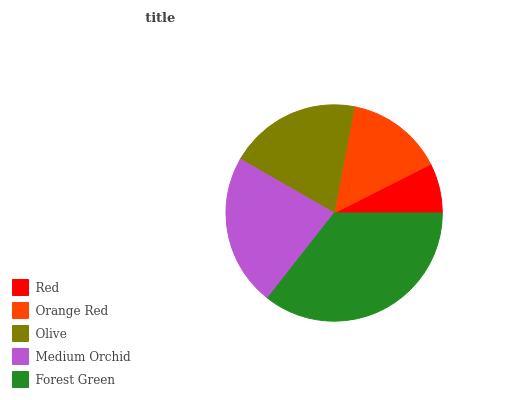Is Red the minimum?
Answer yes or no. Yes. Is Forest Green the maximum?
Answer yes or no. Yes. Is Orange Red the minimum?
Answer yes or no. No. Is Orange Red the maximum?
Answer yes or no. No. Is Orange Red greater than Red?
Answer yes or no. Yes. Is Red less than Orange Red?
Answer yes or no. Yes. Is Red greater than Orange Red?
Answer yes or no. No. Is Orange Red less than Red?
Answer yes or no. No. Is Olive the high median?
Answer yes or no. Yes. Is Olive the low median?
Answer yes or no. Yes. Is Medium Orchid the high median?
Answer yes or no. No. Is Red the low median?
Answer yes or no. No. 